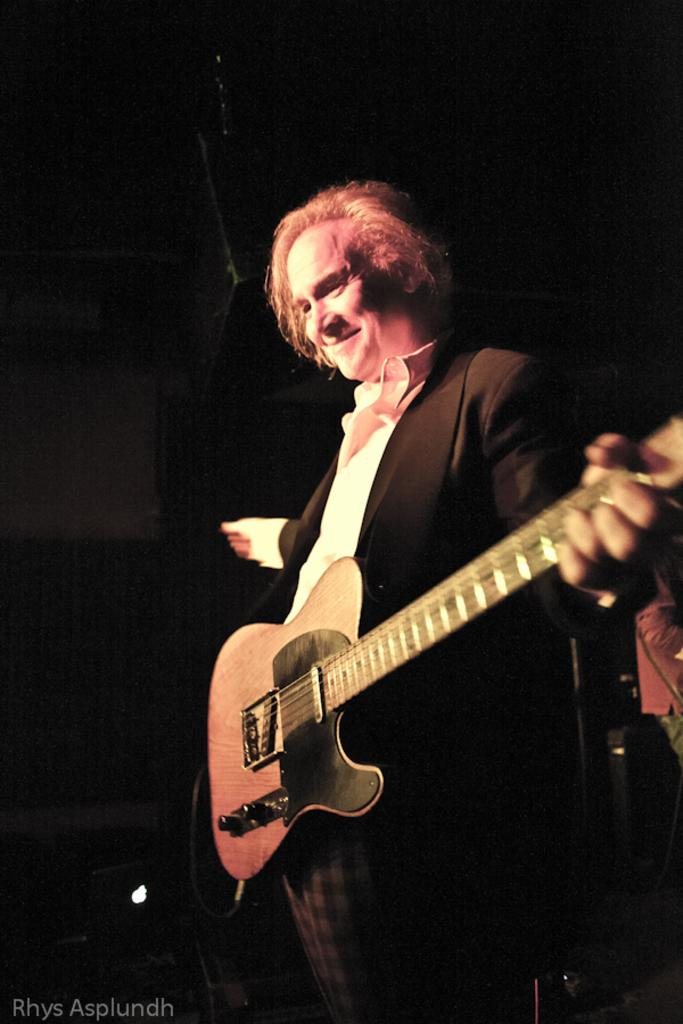Who is present in the image? There is a man in the image. What is the man doing in the image? The man is standing in the image. What object is the man holding in the image? The man is holding a guitar in the image. What type of needle is the man using to perform an operation in the image? There is no operation or needle present in the image; the man is holding a guitar. 